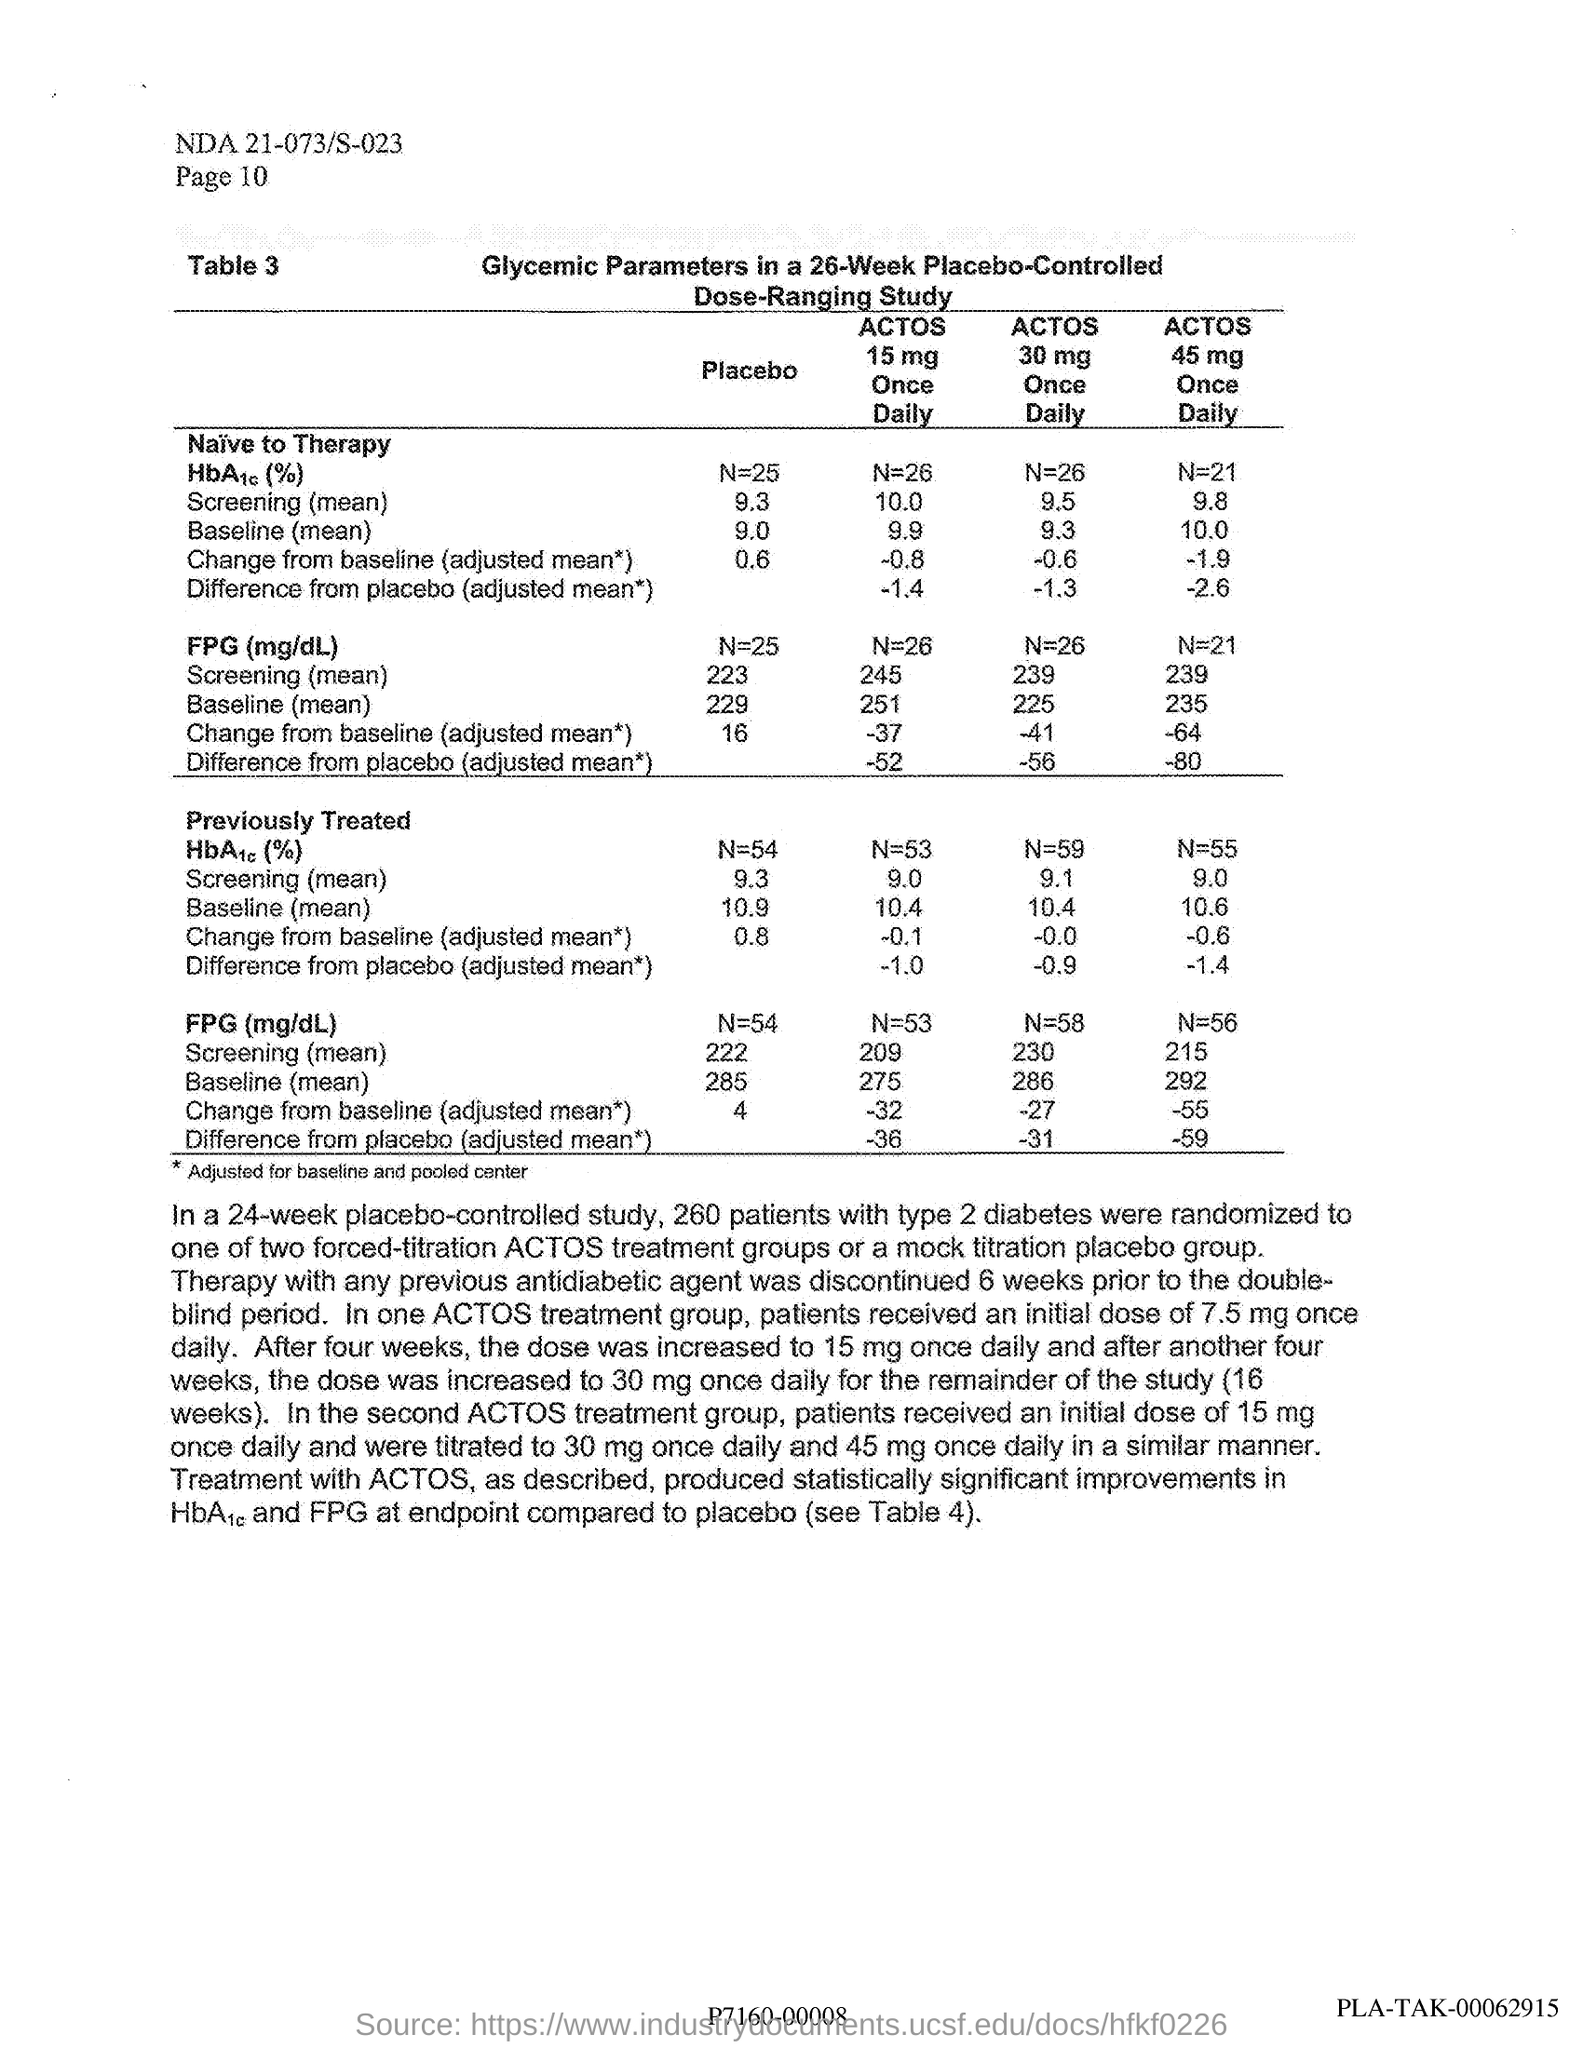Draw attention to some important aspects in this diagram. In the ACTOS treatment group, patients are initially given a daily dose of 7.5 mg. In a 24-week, placebo-controlled study, a total of 260 patients with type 2 diabetes were randomized. In the second treatment group using ACTOS, the recommended starting dose for patients is 15 mg per day. 